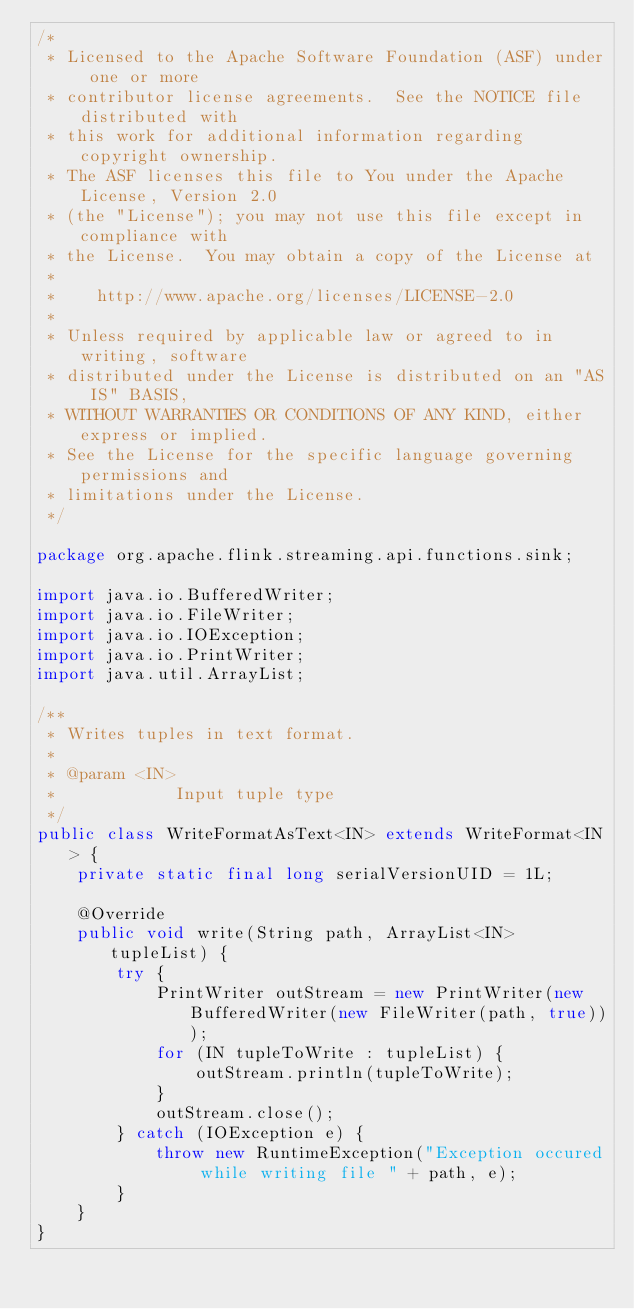Convert code to text. <code><loc_0><loc_0><loc_500><loc_500><_Java_>/*
 * Licensed to the Apache Software Foundation (ASF) under one or more
 * contributor license agreements.  See the NOTICE file distributed with
 * this work for additional information regarding copyright ownership.
 * The ASF licenses this file to You under the Apache License, Version 2.0
 * (the "License"); you may not use this file except in compliance with
 * the License.  You may obtain a copy of the License at
 *
 *    http://www.apache.org/licenses/LICENSE-2.0
 *
 * Unless required by applicable law or agreed to in writing, software
 * distributed under the License is distributed on an "AS IS" BASIS,
 * WITHOUT WARRANTIES OR CONDITIONS OF ANY KIND, either express or implied.
 * See the License for the specific language governing permissions and
 * limitations under the License.
 */

package org.apache.flink.streaming.api.functions.sink;

import java.io.BufferedWriter;
import java.io.FileWriter;
import java.io.IOException;
import java.io.PrintWriter;
import java.util.ArrayList;

/**
 * Writes tuples in text format.
 *
 * @param <IN>
 *            Input tuple type
 */
public class WriteFormatAsText<IN> extends WriteFormat<IN> {
	private static final long serialVersionUID = 1L;

	@Override
	public void write(String path, ArrayList<IN> tupleList) {
		try {
			PrintWriter outStream = new PrintWriter(new BufferedWriter(new FileWriter(path, true)));
			for (IN tupleToWrite : tupleList) {
				outStream.println(tupleToWrite);
			}
			outStream.close();
		} catch (IOException e) {
			throw new RuntimeException("Exception occured while writing file " + path, e);
		}
	}
}
</code> 